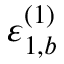<formula> <loc_0><loc_0><loc_500><loc_500>\varepsilon _ { 1 , b } ^ { ( 1 ) }</formula> 